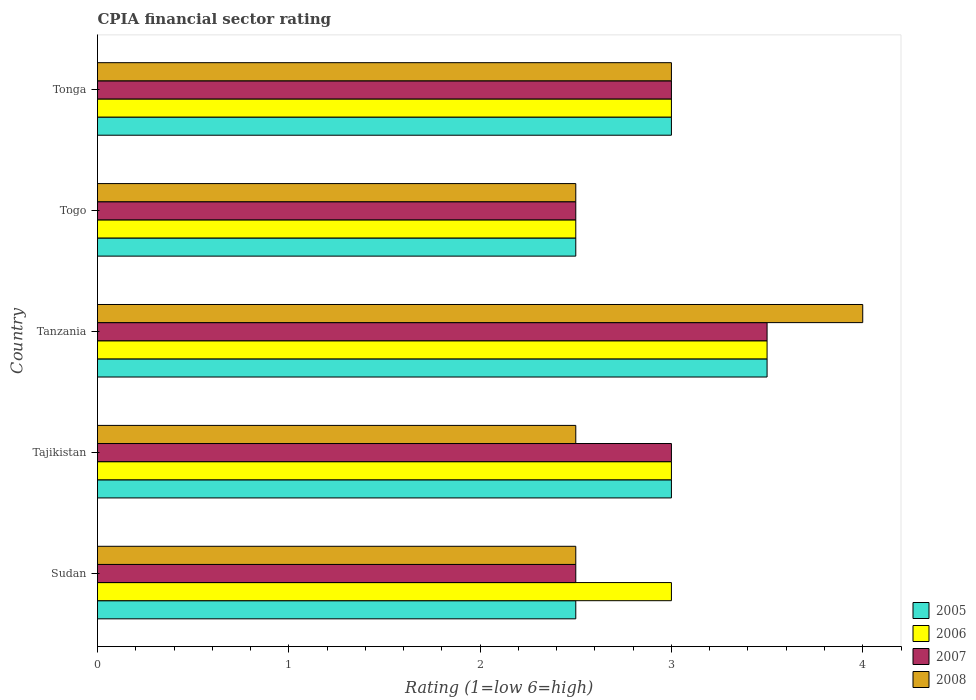How many different coloured bars are there?
Your answer should be compact. 4. Are the number of bars per tick equal to the number of legend labels?
Ensure brevity in your answer.  Yes. Are the number of bars on each tick of the Y-axis equal?
Offer a very short reply. Yes. How many bars are there on the 3rd tick from the top?
Ensure brevity in your answer.  4. How many bars are there on the 2nd tick from the bottom?
Give a very brief answer. 4. What is the label of the 5th group of bars from the top?
Your answer should be compact. Sudan. In how many cases, is the number of bars for a given country not equal to the number of legend labels?
Offer a very short reply. 0. Across all countries, what is the maximum CPIA rating in 2008?
Your answer should be very brief. 4. Across all countries, what is the minimum CPIA rating in 2006?
Your answer should be compact. 2.5. In which country was the CPIA rating in 2006 maximum?
Your answer should be very brief. Tanzania. In which country was the CPIA rating in 2005 minimum?
Make the answer very short. Sudan. What is the difference between the CPIA rating in 2008 in Togo and that in Tonga?
Make the answer very short. -0.5. In how many countries, is the CPIA rating in 2007 greater than 2.6 ?
Make the answer very short. 3. Is the CPIA rating in 2008 in Tanzania less than that in Tonga?
Offer a terse response. No. Is the difference between the CPIA rating in 2007 in Tajikistan and Tonga greater than the difference between the CPIA rating in 2005 in Tajikistan and Tonga?
Provide a short and direct response. No. What is the difference between the highest and the second highest CPIA rating in 2008?
Ensure brevity in your answer.  1. In how many countries, is the CPIA rating in 2006 greater than the average CPIA rating in 2006 taken over all countries?
Your answer should be very brief. 1. Is the sum of the CPIA rating in 2007 in Sudan and Tanzania greater than the maximum CPIA rating in 2008 across all countries?
Ensure brevity in your answer.  Yes. What does the 1st bar from the top in Tonga represents?
Give a very brief answer. 2008. Are all the bars in the graph horizontal?
Offer a terse response. Yes. What is the difference between two consecutive major ticks on the X-axis?
Your answer should be very brief. 1. Does the graph contain grids?
Keep it short and to the point. No. How are the legend labels stacked?
Keep it short and to the point. Vertical. What is the title of the graph?
Provide a short and direct response. CPIA financial sector rating. Does "1966" appear as one of the legend labels in the graph?
Keep it short and to the point. No. What is the label or title of the X-axis?
Offer a very short reply. Rating (1=low 6=high). What is the Rating (1=low 6=high) of 2006 in Sudan?
Make the answer very short. 3. What is the Rating (1=low 6=high) of 2007 in Sudan?
Keep it short and to the point. 2.5. What is the Rating (1=low 6=high) of 2008 in Sudan?
Give a very brief answer. 2.5. What is the Rating (1=low 6=high) of 2005 in Tajikistan?
Your answer should be compact. 3. What is the Rating (1=low 6=high) in 2006 in Tajikistan?
Provide a short and direct response. 3. What is the Rating (1=low 6=high) in 2007 in Tajikistan?
Offer a terse response. 3. What is the Rating (1=low 6=high) of 2005 in Tanzania?
Your answer should be compact. 3.5. What is the Rating (1=low 6=high) of 2006 in Tanzania?
Ensure brevity in your answer.  3.5. What is the Rating (1=low 6=high) in 2008 in Tanzania?
Offer a terse response. 4. What is the Rating (1=low 6=high) of 2005 in Togo?
Ensure brevity in your answer.  2.5. What is the Rating (1=low 6=high) of 2007 in Togo?
Give a very brief answer. 2.5. What is the Rating (1=low 6=high) in 2005 in Tonga?
Keep it short and to the point. 3. What is the Rating (1=low 6=high) of 2008 in Tonga?
Give a very brief answer. 3. Across all countries, what is the maximum Rating (1=low 6=high) in 2005?
Ensure brevity in your answer.  3.5. Across all countries, what is the maximum Rating (1=low 6=high) of 2007?
Provide a short and direct response. 3.5. Across all countries, what is the maximum Rating (1=low 6=high) in 2008?
Provide a short and direct response. 4. Across all countries, what is the minimum Rating (1=low 6=high) in 2005?
Ensure brevity in your answer.  2.5. Across all countries, what is the minimum Rating (1=low 6=high) in 2006?
Provide a succinct answer. 2.5. Across all countries, what is the minimum Rating (1=low 6=high) of 2007?
Keep it short and to the point. 2.5. Across all countries, what is the minimum Rating (1=low 6=high) in 2008?
Keep it short and to the point. 2.5. What is the total Rating (1=low 6=high) of 2005 in the graph?
Keep it short and to the point. 14.5. What is the total Rating (1=low 6=high) of 2008 in the graph?
Your answer should be very brief. 14.5. What is the difference between the Rating (1=low 6=high) of 2005 in Sudan and that in Tajikistan?
Provide a succinct answer. -0.5. What is the difference between the Rating (1=low 6=high) of 2008 in Sudan and that in Tajikistan?
Offer a very short reply. 0. What is the difference between the Rating (1=low 6=high) of 2005 in Sudan and that in Tanzania?
Give a very brief answer. -1. What is the difference between the Rating (1=low 6=high) in 2006 in Sudan and that in Tanzania?
Ensure brevity in your answer.  -0.5. What is the difference between the Rating (1=low 6=high) of 2007 in Sudan and that in Tanzania?
Your answer should be compact. -1. What is the difference between the Rating (1=low 6=high) in 2005 in Sudan and that in Togo?
Offer a terse response. 0. What is the difference between the Rating (1=low 6=high) in 2006 in Sudan and that in Togo?
Your answer should be compact. 0.5. What is the difference between the Rating (1=low 6=high) in 2007 in Sudan and that in Togo?
Your answer should be very brief. 0. What is the difference between the Rating (1=low 6=high) of 2005 in Sudan and that in Tonga?
Your response must be concise. -0.5. What is the difference between the Rating (1=low 6=high) of 2007 in Sudan and that in Tonga?
Give a very brief answer. -0.5. What is the difference between the Rating (1=low 6=high) in 2005 in Tajikistan and that in Tanzania?
Keep it short and to the point. -0.5. What is the difference between the Rating (1=low 6=high) in 2006 in Tajikistan and that in Togo?
Give a very brief answer. 0.5. What is the difference between the Rating (1=low 6=high) in 2008 in Tajikistan and that in Togo?
Offer a very short reply. 0. What is the difference between the Rating (1=low 6=high) of 2006 in Tajikistan and that in Tonga?
Ensure brevity in your answer.  0. What is the difference between the Rating (1=low 6=high) of 2007 in Tajikistan and that in Tonga?
Offer a very short reply. 0. What is the difference between the Rating (1=low 6=high) in 2006 in Tanzania and that in Togo?
Your answer should be compact. 1. What is the difference between the Rating (1=low 6=high) in 2007 in Tanzania and that in Togo?
Ensure brevity in your answer.  1. What is the difference between the Rating (1=low 6=high) in 2008 in Tanzania and that in Togo?
Ensure brevity in your answer.  1.5. What is the difference between the Rating (1=low 6=high) in 2005 in Tanzania and that in Tonga?
Your response must be concise. 0.5. What is the difference between the Rating (1=low 6=high) in 2007 in Tanzania and that in Tonga?
Offer a very short reply. 0.5. What is the difference between the Rating (1=low 6=high) in 2006 in Togo and that in Tonga?
Provide a succinct answer. -0.5. What is the difference between the Rating (1=low 6=high) of 2007 in Togo and that in Tonga?
Ensure brevity in your answer.  -0.5. What is the difference between the Rating (1=low 6=high) of 2008 in Togo and that in Tonga?
Your response must be concise. -0.5. What is the difference between the Rating (1=low 6=high) of 2005 in Sudan and the Rating (1=low 6=high) of 2008 in Tajikistan?
Your response must be concise. 0. What is the difference between the Rating (1=low 6=high) of 2007 in Sudan and the Rating (1=low 6=high) of 2008 in Tajikistan?
Provide a short and direct response. 0. What is the difference between the Rating (1=low 6=high) of 2005 in Sudan and the Rating (1=low 6=high) of 2007 in Tanzania?
Your answer should be very brief. -1. What is the difference between the Rating (1=low 6=high) of 2006 in Sudan and the Rating (1=low 6=high) of 2007 in Tanzania?
Offer a very short reply. -0.5. What is the difference between the Rating (1=low 6=high) of 2006 in Sudan and the Rating (1=low 6=high) of 2008 in Tanzania?
Give a very brief answer. -1. What is the difference between the Rating (1=low 6=high) of 2005 in Sudan and the Rating (1=low 6=high) of 2007 in Togo?
Provide a short and direct response. 0. What is the difference between the Rating (1=low 6=high) in 2005 in Sudan and the Rating (1=low 6=high) in 2008 in Togo?
Your answer should be very brief. 0. What is the difference between the Rating (1=low 6=high) of 2006 in Sudan and the Rating (1=low 6=high) of 2007 in Togo?
Your answer should be very brief. 0.5. What is the difference between the Rating (1=low 6=high) in 2006 in Sudan and the Rating (1=low 6=high) in 2008 in Togo?
Offer a very short reply. 0.5. What is the difference between the Rating (1=low 6=high) of 2005 in Sudan and the Rating (1=low 6=high) of 2008 in Tonga?
Your answer should be very brief. -0.5. What is the difference between the Rating (1=low 6=high) of 2006 in Sudan and the Rating (1=low 6=high) of 2008 in Tonga?
Your answer should be compact. 0. What is the difference between the Rating (1=low 6=high) of 2007 in Sudan and the Rating (1=low 6=high) of 2008 in Tonga?
Your answer should be compact. -0.5. What is the difference between the Rating (1=low 6=high) in 2005 in Tajikistan and the Rating (1=low 6=high) in 2008 in Tanzania?
Offer a terse response. -1. What is the difference between the Rating (1=low 6=high) in 2006 in Tajikistan and the Rating (1=low 6=high) in 2008 in Tanzania?
Your answer should be very brief. -1. What is the difference between the Rating (1=low 6=high) of 2005 in Tajikistan and the Rating (1=low 6=high) of 2006 in Togo?
Your answer should be very brief. 0.5. What is the difference between the Rating (1=low 6=high) of 2006 in Tajikistan and the Rating (1=low 6=high) of 2007 in Togo?
Your response must be concise. 0.5. What is the difference between the Rating (1=low 6=high) in 2006 in Tajikistan and the Rating (1=low 6=high) in 2008 in Togo?
Offer a very short reply. 0.5. What is the difference between the Rating (1=low 6=high) in 2005 in Tajikistan and the Rating (1=low 6=high) in 2008 in Tonga?
Give a very brief answer. 0. What is the difference between the Rating (1=low 6=high) in 2006 in Tajikistan and the Rating (1=low 6=high) in 2007 in Tonga?
Offer a terse response. 0. What is the difference between the Rating (1=low 6=high) in 2007 in Tajikistan and the Rating (1=low 6=high) in 2008 in Tonga?
Provide a short and direct response. 0. What is the difference between the Rating (1=low 6=high) of 2006 in Tanzania and the Rating (1=low 6=high) of 2008 in Togo?
Offer a very short reply. 1. What is the difference between the Rating (1=low 6=high) in 2007 in Tanzania and the Rating (1=low 6=high) in 2008 in Togo?
Offer a very short reply. 1. What is the difference between the Rating (1=low 6=high) in 2005 in Tanzania and the Rating (1=low 6=high) in 2006 in Tonga?
Provide a succinct answer. 0.5. What is the difference between the Rating (1=low 6=high) in 2005 in Tanzania and the Rating (1=low 6=high) in 2007 in Tonga?
Offer a terse response. 0.5. What is the difference between the Rating (1=low 6=high) in 2005 in Togo and the Rating (1=low 6=high) in 2006 in Tonga?
Provide a succinct answer. -0.5. What is the difference between the Rating (1=low 6=high) in 2005 in Togo and the Rating (1=low 6=high) in 2008 in Tonga?
Make the answer very short. -0.5. What is the average Rating (1=low 6=high) of 2006 per country?
Your answer should be compact. 3. What is the average Rating (1=low 6=high) of 2008 per country?
Provide a short and direct response. 2.9. What is the difference between the Rating (1=low 6=high) of 2005 and Rating (1=low 6=high) of 2006 in Sudan?
Your answer should be compact. -0.5. What is the difference between the Rating (1=low 6=high) in 2005 and Rating (1=low 6=high) in 2008 in Sudan?
Keep it short and to the point. 0. What is the difference between the Rating (1=low 6=high) in 2006 and Rating (1=low 6=high) in 2007 in Sudan?
Provide a succinct answer. 0.5. What is the difference between the Rating (1=low 6=high) of 2006 and Rating (1=low 6=high) of 2008 in Sudan?
Keep it short and to the point. 0.5. What is the difference between the Rating (1=low 6=high) of 2005 and Rating (1=low 6=high) of 2006 in Tajikistan?
Offer a terse response. 0. What is the difference between the Rating (1=low 6=high) of 2005 and Rating (1=low 6=high) of 2007 in Tajikistan?
Give a very brief answer. 0. What is the difference between the Rating (1=low 6=high) in 2007 and Rating (1=low 6=high) in 2008 in Tajikistan?
Give a very brief answer. 0.5. What is the difference between the Rating (1=low 6=high) in 2005 and Rating (1=low 6=high) in 2007 in Tanzania?
Your response must be concise. 0. What is the difference between the Rating (1=low 6=high) in 2006 and Rating (1=low 6=high) in 2008 in Tanzania?
Make the answer very short. -0.5. What is the difference between the Rating (1=low 6=high) of 2005 and Rating (1=low 6=high) of 2006 in Togo?
Offer a very short reply. 0. What is the difference between the Rating (1=low 6=high) of 2005 and Rating (1=low 6=high) of 2008 in Togo?
Give a very brief answer. 0. What is the difference between the Rating (1=low 6=high) of 2006 and Rating (1=low 6=high) of 2008 in Togo?
Keep it short and to the point. 0. What is the difference between the Rating (1=low 6=high) of 2005 and Rating (1=low 6=high) of 2006 in Tonga?
Your response must be concise. 0. What is the difference between the Rating (1=low 6=high) in 2005 and Rating (1=low 6=high) in 2007 in Tonga?
Your answer should be very brief. 0. What is the difference between the Rating (1=low 6=high) of 2007 and Rating (1=low 6=high) of 2008 in Tonga?
Your answer should be compact. 0. What is the ratio of the Rating (1=low 6=high) in 2005 in Sudan to that in Tajikistan?
Your response must be concise. 0.83. What is the ratio of the Rating (1=low 6=high) in 2008 in Sudan to that in Tajikistan?
Your response must be concise. 1. What is the ratio of the Rating (1=low 6=high) in 2005 in Sudan to that in Tanzania?
Your answer should be compact. 0.71. What is the ratio of the Rating (1=low 6=high) in 2006 in Sudan to that in Tanzania?
Your answer should be compact. 0.86. What is the ratio of the Rating (1=low 6=high) in 2007 in Sudan to that in Tanzania?
Your answer should be very brief. 0.71. What is the ratio of the Rating (1=low 6=high) of 2006 in Sudan to that in Togo?
Ensure brevity in your answer.  1.2. What is the ratio of the Rating (1=low 6=high) in 2007 in Sudan to that in Togo?
Provide a short and direct response. 1. What is the ratio of the Rating (1=low 6=high) in 2008 in Sudan to that in Togo?
Offer a very short reply. 1. What is the ratio of the Rating (1=low 6=high) in 2006 in Sudan to that in Tonga?
Offer a very short reply. 1. What is the ratio of the Rating (1=low 6=high) of 2007 in Sudan to that in Tonga?
Provide a succinct answer. 0.83. What is the ratio of the Rating (1=low 6=high) in 2008 in Sudan to that in Tonga?
Offer a very short reply. 0.83. What is the ratio of the Rating (1=low 6=high) of 2005 in Tajikistan to that in Tanzania?
Your answer should be very brief. 0.86. What is the ratio of the Rating (1=low 6=high) in 2006 in Tajikistan to that in Tanzania?
Offer a very short reply. 0.86. What is the ratio of the Rating (1=low 6=high) of 2008 in Tajikistan to that in Tanzania?
Keep it short and to the point. 0.62. What is the ratio of the Rating (1=low 6=high) of 2005 in Tajikistan to that in Togo?
Offer a terse response. 1.2. What is the ratio of the Rating (1=low 6=high) in 2007 in Tajikistan to that in Tonga?
Your response must be concise. 1. What is the ratio of the Rating (1=low 6=high) in 2008 in Tajikistan to that in Tonga?
Provide a succinct answer. 0.83. What is the ratio of the Rating (1=low 6=high) in 2005 in Tanzania to that in Togo?
Keep it short and to the point. 1.4. What is the ratio of the Rating (1=low 6=high) in 2007 in Tanzania to that in Togo?
Your answer should be very brief. 1.4. What is the ratio of the Rating (1=low 6=high) in 2006 in Tanzania to that in Tonga?
Your response must be concise. 1.17. What is the ratio of the Rating (1=low 6=high) of 2007 in Tanzania to that in Tonga?
Offer a terse response. 1.17. What is the ratio of the Rating (1=low 6=high) in 2008 in Tanzania to that in Tonga?
Provide a succinct answer. 1.33. What is the ratio of the Rating (1=low 6=high) in 2006 in Togo to that in Tonga?
Ensure brevity in your answer.  0.83. What is the ratio of the Rating (1=low 6=high) in 2007 in Togo to that in Tonga?
Your response must be concise. 0.83. What is the difference between the highest and the second highest Rating (1=low 6=high) of 2005?
Offer a very short reply. 0.5. What is the difference between the highest and the lowest Rating (1=low 6=high) of 2006?
Ensure brevity in your answer.  1. What is the difference between the highest and the lowest Rating (1=low 6=high) in 2007?
Your response must be concise. 1. 